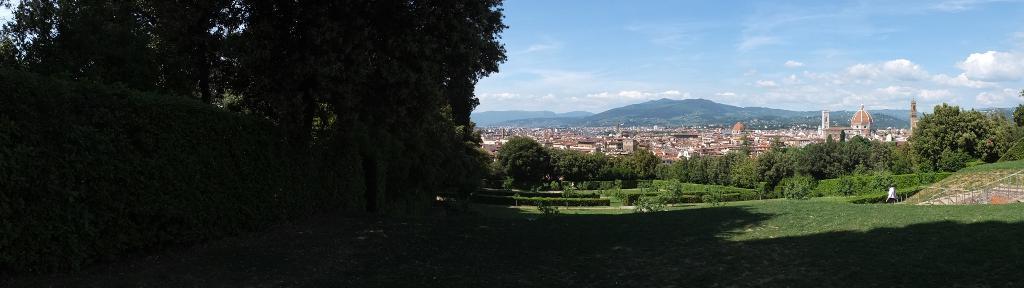Please provide a concise description of this image. In this image there are trees. At the bottom there is grass and we can see hedges. In the background there are buildings, hills and sky. 